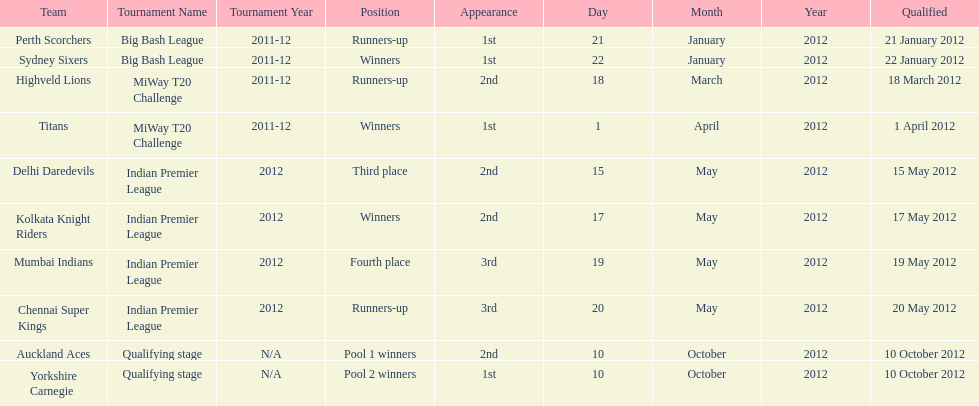What is the total number of teams? 10. 